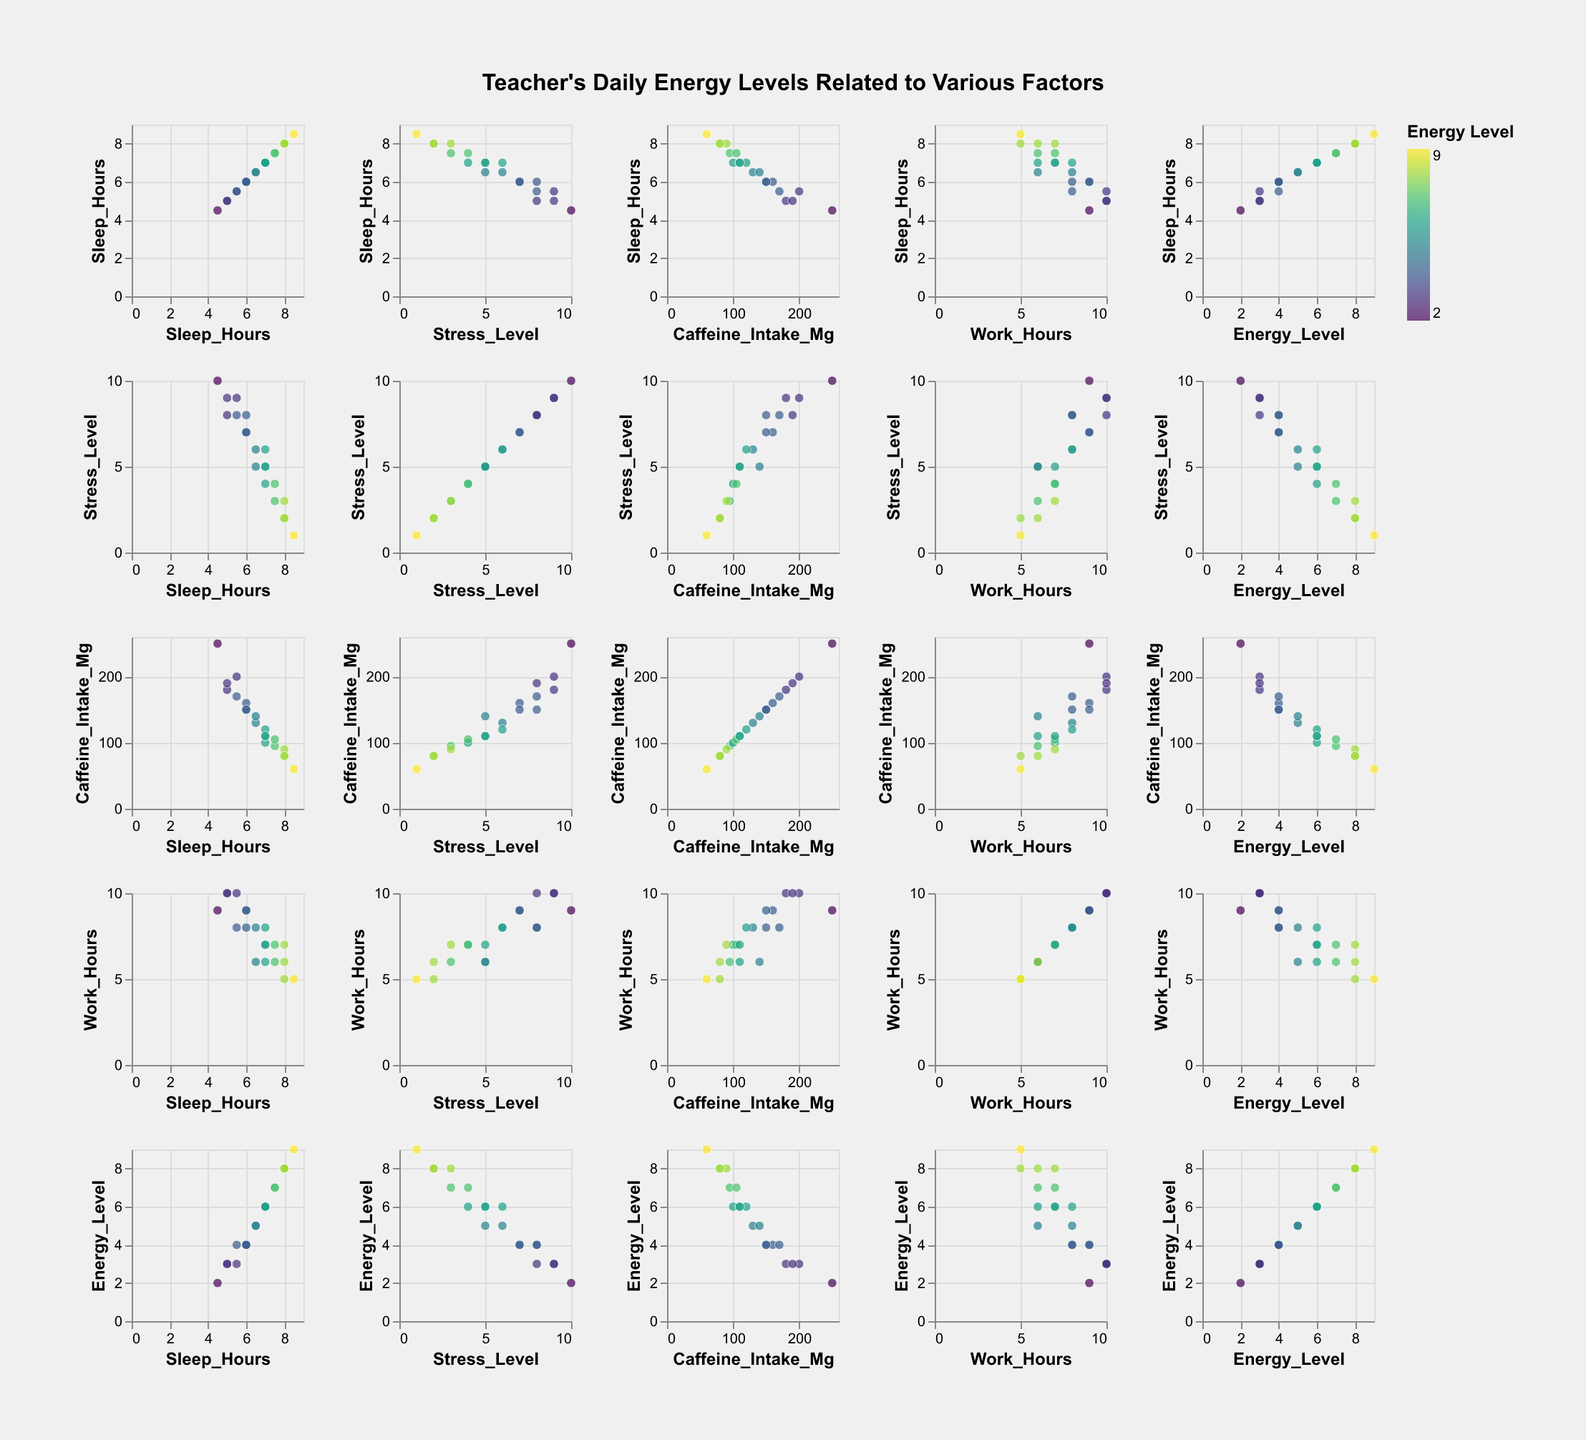How does the amount of sleep correlate with stress levels? Examine the scatter plot section where Sleep Hours is on the y-axis and Stress Level is on the x-axis. Look for any overall trend or typical pattern that emerges from the data points. If there is a descending trend, it means as sleep hours increase, stress levels tend to decrease and vice versa.
Answer: Generally, higher sleep hours correlate with lower stress levels Which factors seem to have the strongest correlation with energy levels? Look at all the scatter plots where Energy Level is one of the axes. Determine which one shows the strongest visual correlation (positive or negative), which will typically be where the data points closely align along a diagonal rather than being scattered randomly.
Answer: Sleep Hours and Energy Level have a strong positive correlation What is the energy level for the data point with the highest caffeine intake? Find the scatter plot where Caffeine Intake Mg is on one axis and Energy Level is on the other. Identify the highest caffeine intake value (250 mg) and note its corresponding energy level.
Answer: The energy level is 2 Between Sleep Hours and Work Hours, which variable has a stronger impact on energy levels? Compare the scatter plots between Sleep Hours vs Energy Level and Work Hours vs Energy Level. Determine which one shows a clearer trend (less variability in energy levels for different values).
Answer: Sleep Hours have a stronger impact on energy levels Do higher stress levels generally correlate with higher caffeine intake? Check the scatter plot where Stress Levels are on one axis and Caffeine Intake Mg is on the other. Look for an overall trend among the data points to see if higher stress levels tend to align with higher caffeine intake values.
Answer: Yes, there is a general trend that higher stress levels correspond with higher caffeine intake How many data points have a sleep duration of 6 hours? Look at the tick marks for Sleep Hours and count the number of data points directly above the tick mark labeled 6 in the scatter plots involving Sleep Hours.
Answer: There are 3 data points Which data point has the highest energy level and what are its corresponding other values? Look for the highest value on any scatter plot where Energy Level is an axis (Energy Level on the color scale can also guide you). Track back the corresponding Sleep Hours, Stress Level, Caffeine Intake, and Work Hours for this point.
Answer: The data point with the highest energy level (9) has 8.5 Sleep Hours, 1 Stress Level, 60 Mg Caffeine Intake, and 5 Work Hours Is there a clear trend between work hours and energy levels? Examine the scatter plot where Work Hours is on one axis and Energy Level is on the other. Look for an overall pattern that can indicate a positive, negative, or no trend.
Answer: There is no clear trend How does caffeine intake vary with different levels of sleep hours? Look at the scatter plot where Sleep Hours is on one axis and Caffeine Intake Mg is on the other. Observe the pattern of data points to see how caffeine intake changes with varying sleep hours.
Answer: Caffeine intake tends to increase as Sleep Hours decrease Looking at the scatter plot matrix, which two variables appear least correlated based on the scatter plots? Review all the scatter plots to identify a pair where the data points do not form any distinguishable trend or cluster together, indicating a weak or no correlation.
Answer: There appears to be little correlation between Caffeine Intake and Work Hours 